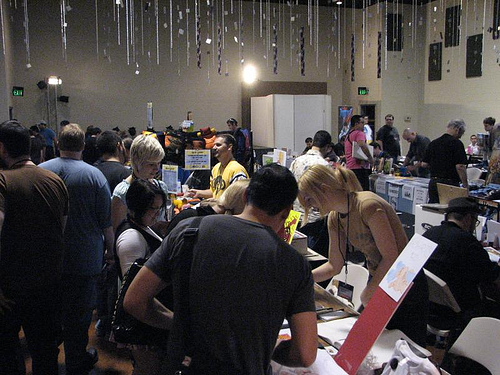<image>
Is the light in front of the man? Yes. The light is positioned in front of the man, appearing closer to the camera viewpoint. 